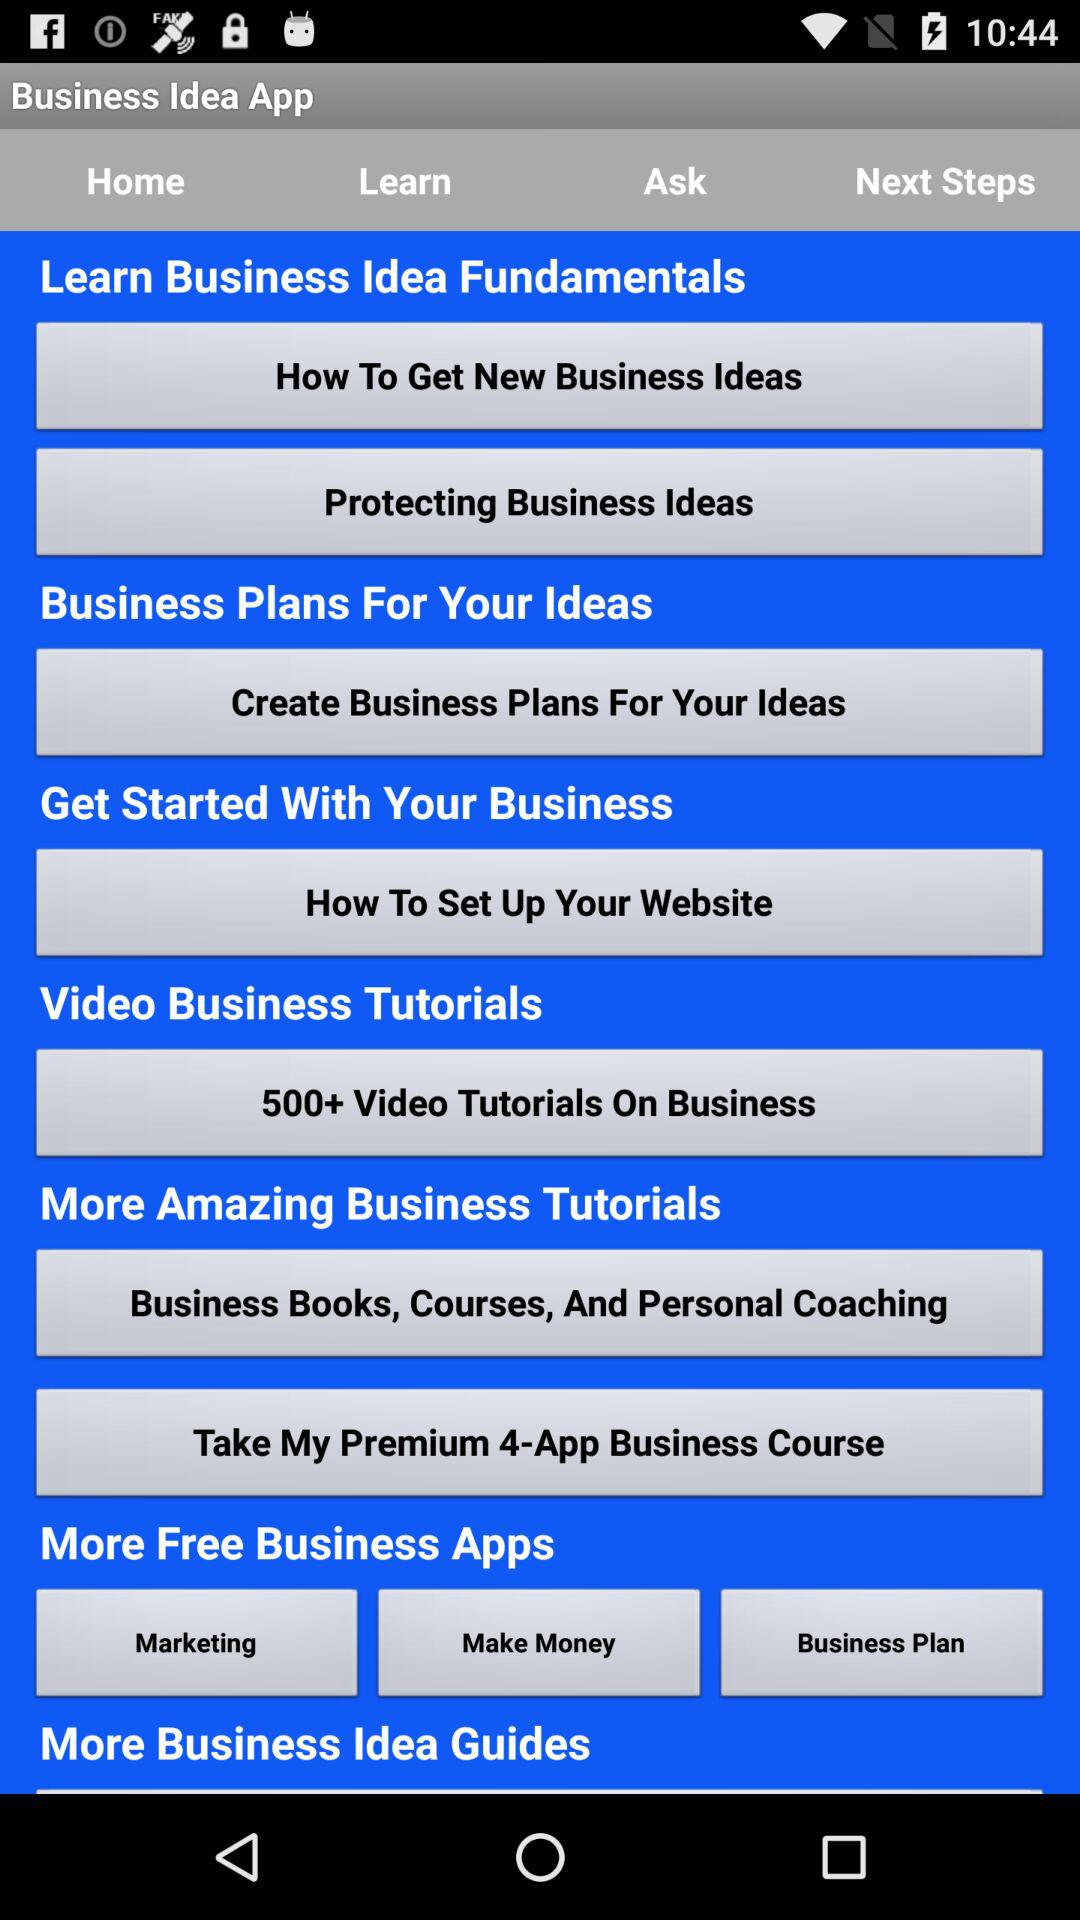What is the name of the application? The name of the application is "Business Idea". 